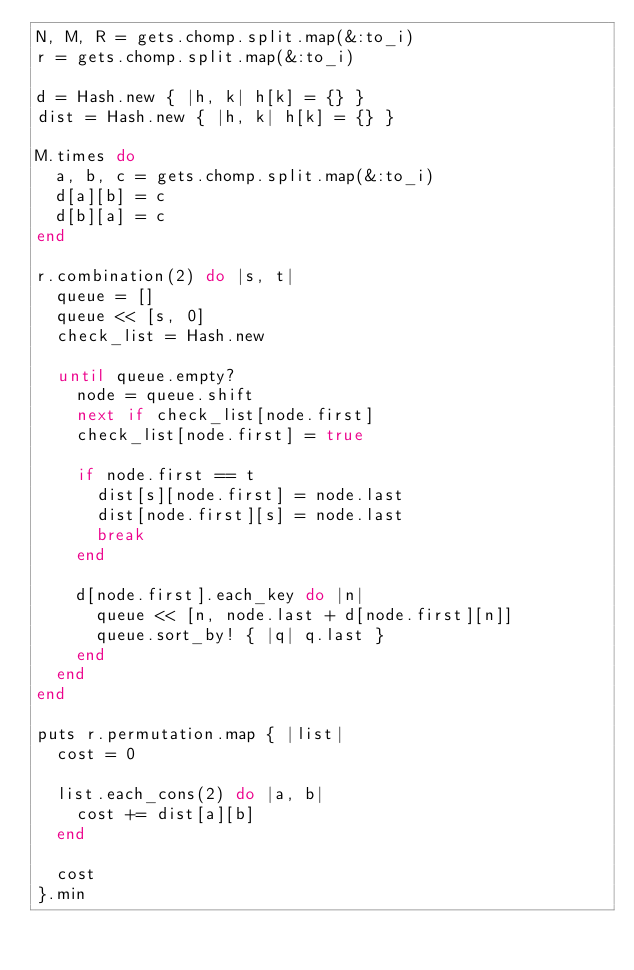Convert code to text. <code><loc_0><loc_0><loc_500><loc_500><_Ruby_>N, M, R = gets.chomp.split.map(&:to_i)
r = gets.chomp.split.map(&:to_i)

d = Hash.new { |h, k| h[k] = {} }
dist = Hash.new { |h, k| h[k] = {} }

M.times do
  a, b, c = gets.chomp.split.map(&:to_i)
  d[a][b] = c
  d[b][a] = c
end

r.combination(2) do |s, t|
  queue = []
  queue << [s, 0]
  check_list = Hash.new

  until queue.empty?
    node = queue.shift
    next if check_list[node.first]
    check_list[node.first] = true

    if node.first == t
      dist[s][node.first] = node.last
      dist[node.first][s] = node.last
      break
    end

    d[node.first].each_key do |n|
      queue << [n, node.last + d[node.first][n]]
      queue.sort_by! { |q| q.last }
    end
  end
end

puts r.permutation.map { |list|
  cost = 0

  list.each_cons(2) do |a, b|
    cost += dist[a][b]
  end

  cost
}.min
</code> 